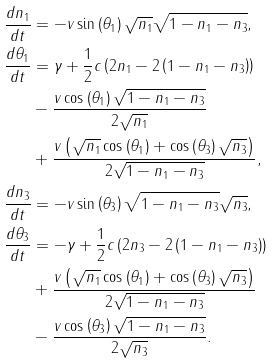<formula> <loc_0><loc_0><loc_500><loc_500>\frac { d n _ { 1 } } { d t } & = - v \sin \left ( \theta _ { 1 } \right ) \sqrt { n _ { 1 } } \sqrt { 1 - n _ { 1 } - n _ { 3 } } , \\ \frac { d \theta _ { 1 } } { d t } & = \gamma + \frac { 1 } { 2 } c \left ( 2 n _ { 1 } - 2 \left ( 1 - n _ { 1 } - n _ { 3 } \right ) \right ) \\ & - \frac { v \cos \left ( \theta _ { 1 } \right ) \sqrt { 1 - n _ { 1 } - n _ { 3 } } } { 2 \sqrt { n _ { 1 } } } \\ & + \frac { v \left ( \sqrt { n _ { 1 } } \cos \left ( \theta _ { 1 } \right ) + \cos \left ( \theta _ { 3 } \right ) \sqrt { n _ { 3 } } \right ) } { 2 \sqrt { 1 - n _ { 1 } - n _ { 3 } } } , \\ \frac { d n _ { 3 } } { d t } & = - v \sin \left ( \theta _ { 3 } \right ) \sqrt { 1 - n _ { 1 } - n _ { 3 } } \sqrt { n _ { 3 } } , \\ \frac { d \theta _ { 3 } } { d t } & = - \gamma + \frac { 1 } { 2 } c \left ( 2 n _ { 3 } - 2 \left ( 1 - n _ { 1 } - n _ { 3 } \right ) \right ) \\ & + \frac { v \left ( \sqrt { n _ { 1 } } \cos \left ( \theta _ { 1 } \right ) + \cos \left ( \theta _ { 3 } \right ) \sqrt { n _ { 3 } } \right ) } { 2 \sqrt { 1 - n _ { 1 } - n _ { 3 } } } \\ & - \frac { v \cos \left ( \theta _ { 3 } \right ) \sqrt { 1 - n _ { 1 } - n _ { 3 } } } { 2 \sqrt { n _ { 3 } } } .</formula> 